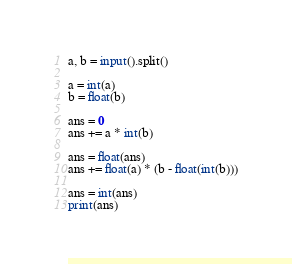Convert code to text. <code><loc_0><loc_0><loc_500><loc_500><_Python_>a, b = input().split()

a = int(a)
b = float(b)

ans = 0
ans += a * int(b)

ans = float(ans)
ans += float(a) * (b - float(int(b)))

ans = int(ans)
print(ans)
</code> 